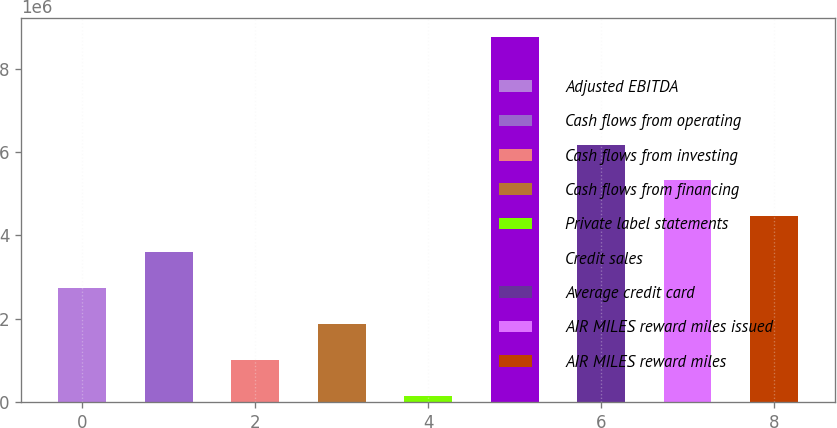<chart> <loc_0><loc_0><loc_500><loc_500><bar_chart><fcel>Adjusted EBITDA<fcel>Cash flows from operating<fcel>Cash flows from investing<fcel>Cash flows from financing<fcel>Private label statements<fcel>Credit sales<fcel>Average credit card<fcel>AIR MILES reward miles issued<fcel>AIR MILES reward miles<nl><fcel>2.7317e+06<fcel>3.5948e+06<fcel>1.00548e+06<fcel>1.86859e+06<fcel>142379<fcel>8.77344e+06<fcel>6.18412e+06<fcel>5.32101e+06<fcel>4.45791e+06<nl></chart> 